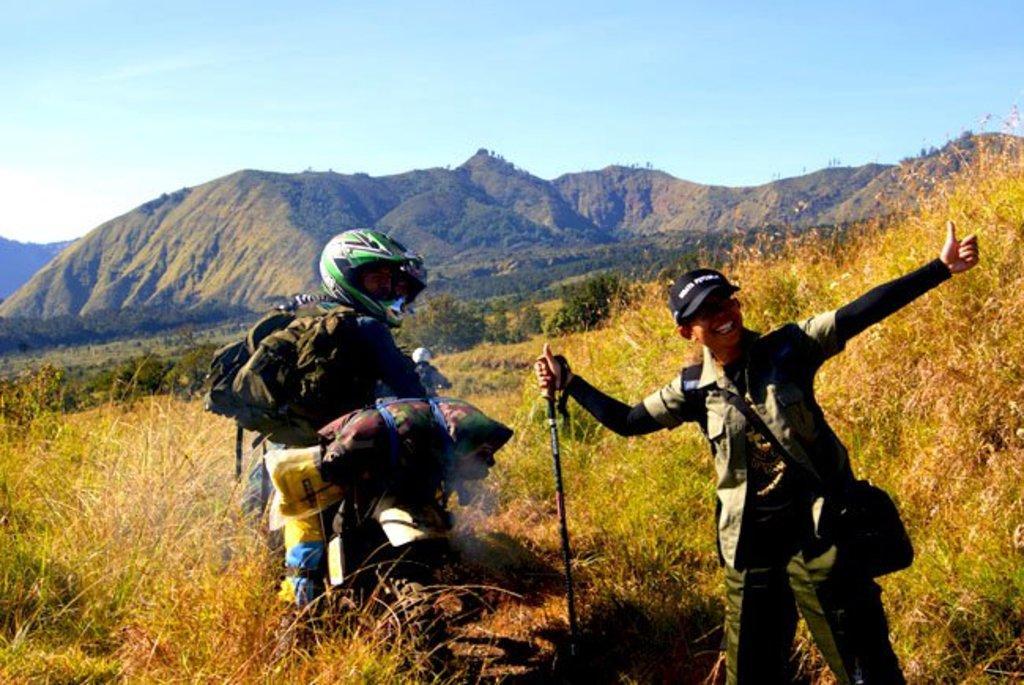Describe this image in one or two sentences. In the image we can see there are two people wearing clothes. This person is wearing cap and carrying a bag on back, and holding a stick in hand. The other person is wearing a helmet. This is a grass, trees, mountain and a sky. 